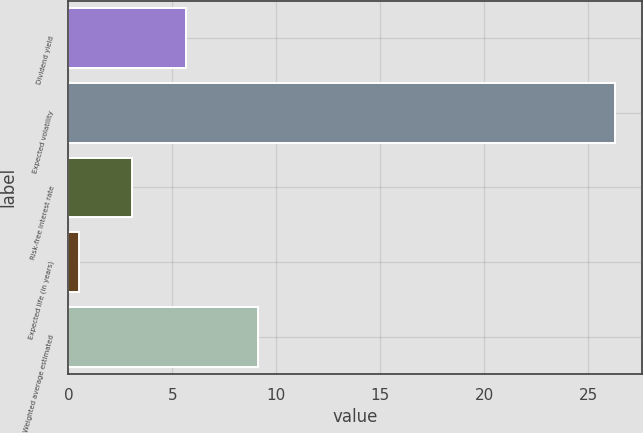Convert chart to OTSL. <chart><loc_0><loc_0><loc_500><loc_500><bar_chart><fcel>Dividend yield<fcel>Expected volatility<fcel>Risk-free interest rate<fcel>Expected life (in years)<fcel>Weighted average estimated<nl><fcel>5.66<fcel>26.3<fcel>3.08<fcel>0.5<fcel>9.14<nl></chart> 